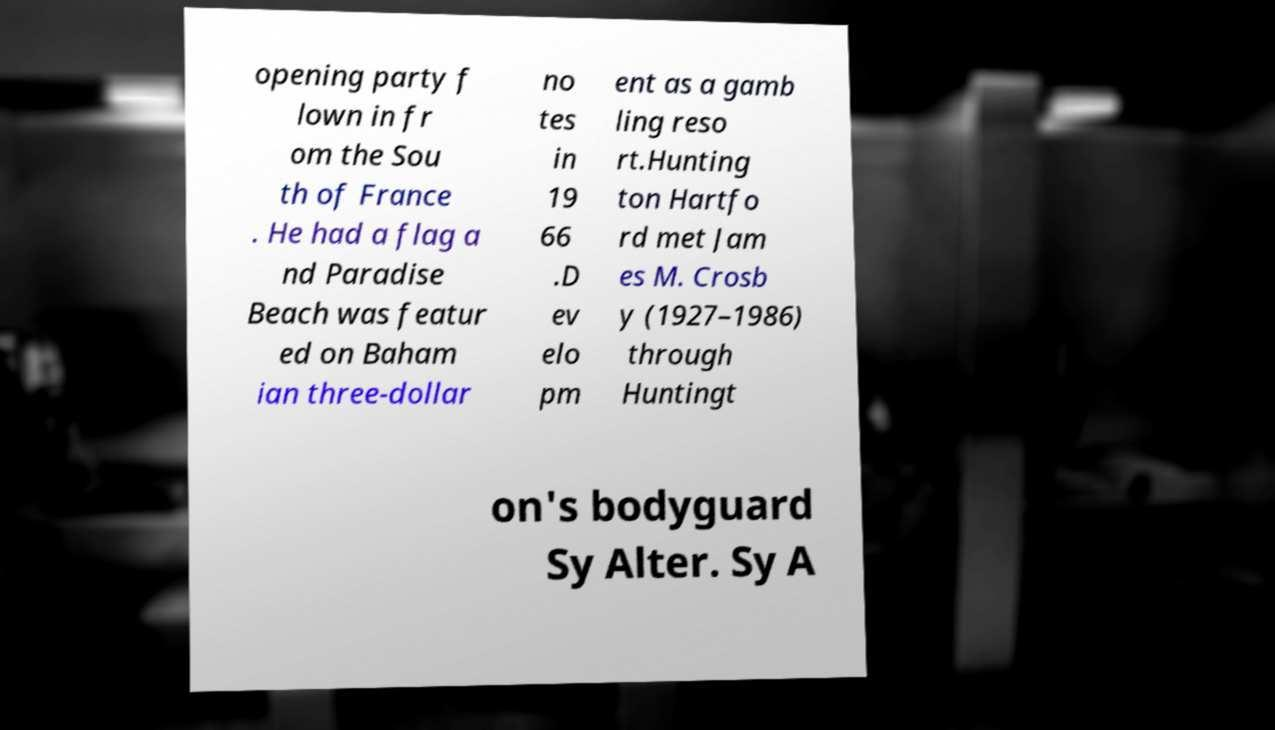Please identify and transcribe the text found in this image. opening party f lown in fr om the Sou th of France . He had a flag a nd Paradise Beach was featur ed on Baham ian three-dollar no tes in 19 66 .D ev elo pm ent as a gamb ling reso rt.Hunting ton Hartfo rd met Jam es M. Crosb y (1927–1986) through Huntingt on's bodyguard Sy Alter. Sy A 